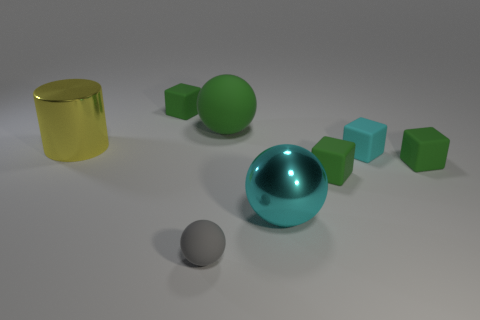What shape is the tiny thing that is the same color as the metallic ball?
Give a very brief answer. Cube. How many things are green objects that are behind the big yellow metal thing or tiny things?
Your response must be concise. 6. Is the number of blue rubber spheres less than the number of small things?
Provide a succinct answer. Yes. There is a big object that is the same material as the big cyan ball; what is its shape?
Provide a short and direct response. Cylinder. Are there any green matte blocks in front of the tiny cyan cube?
Offer a terse response. Yes. Are there fewer green matte balls that are in front of the metal cylinder than tiny green rubber cubes?
Your answer should be very brief. Yes. What is the big yellow cylinder made of?
Your response must be concise. Metal. What color is the large cylinder?
Provide a succinct answer. Yellow. There is a matte object that is both behind the tiny ball and left of the green ball; what is its color?
Your answer should be compact. Green. Is there any other thing that is made of the same material as the cyan block?
Offer a very short reply. Yes. 